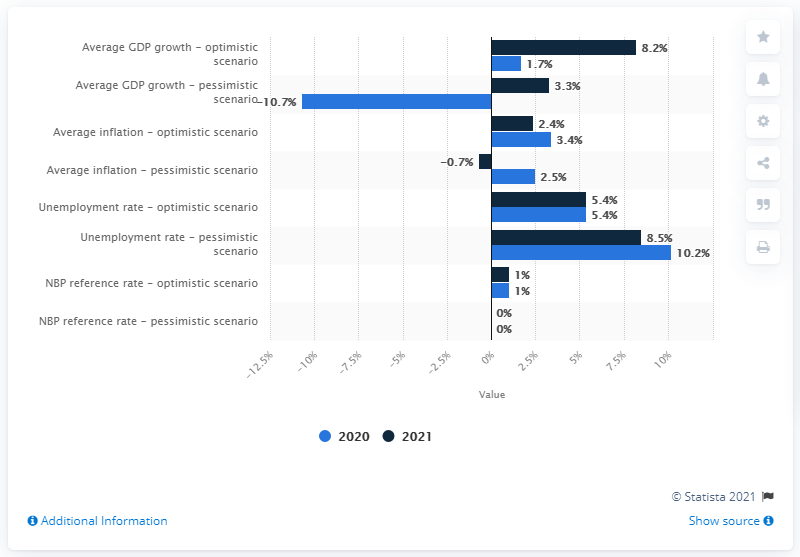Outline some significant characteristics in this image. In a pessimistic scenario, the inflation rate is predicted to rise to as much as 2.5%. The Polish economy is expected to emerge from the crisis in 2021. In a pessimistic scenario, the inflation rate is predicted to rise to a devastating 2.5%. 